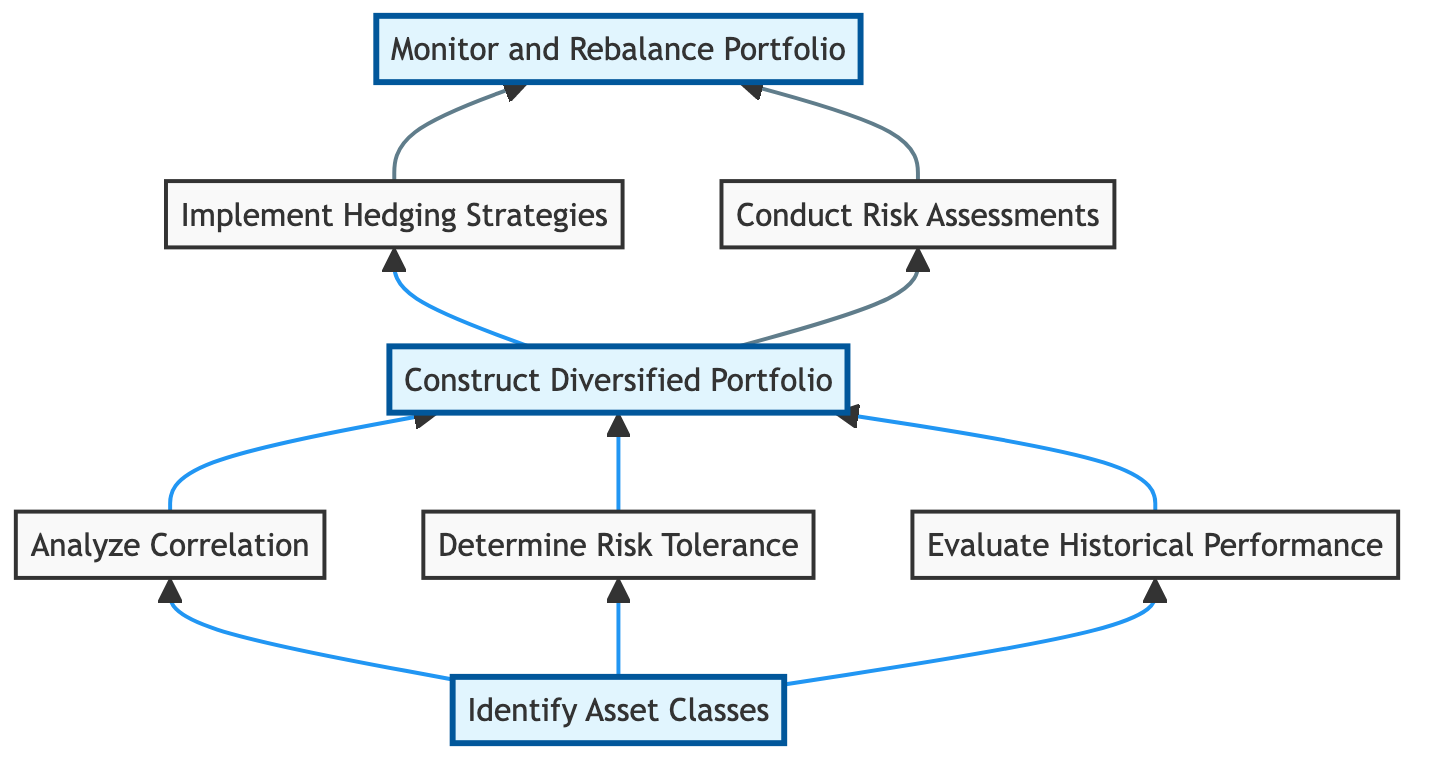What is the first step in the flow chart? The first step is to "Identify Asset Classes" as it is the first element in the diagram that signifies the starting point of the flow.
Answer: Identify Asset Classes How many elements are in the diagram? There are a total of eight elements shown in the diagram, identified by the nodes representing different actions in the portfolio diversification analysis.
Answer: Eight What steps occur before "Construct Diversified Portfolio"? The steps that occur before "Construct Diversified Portfolio" are "Analyze Correlation", "Determine Risk Tolerance", and "Evaluate Historical Performance", as illustrated by the arrows leading into the construction step.
Answer: Analyze Correlation, Determine Risk Tolerance, Evaluate Historical Performance Which element is connected to "Monitor and Rebalance Portfolio"? "Monitor and Rebalance Portfolio" is connected to both "Implement Hedging Strategies" and "Conduct Risk Assessments", as indicated by the directional arrows leading into this node.
Answer: Implement Hedging Strategies, Conduct Risk Assessments What is the relationship between "Evaluate Historical Performance" and "Construct Diversified Portfolio"? "Evaluate Historical Performance" directly feeds into "Construct Diversified Portfolio", indicating that the outcomes of evaluating historical performance influence the construction of the portfolio.
Answer: Direct influence What happens after "Conduct Risk Assessments"? After "Conduct Risk Assessments", the next action is "Monitor and Rebalance Portfolio", meaning that ongoing monitoring and adjustments follow the risk assessments conducted for the portfolio.
Answer: Monitor and Rebalance Portfolio Which step has no outgoing connections? The step "Identify Asset Classes" has no outgoing connections, indicating it is the starting point of the flow without a prerequisite step leading into it.
Answer: Identify Asset Classes How many slots are highlighted in the diagram? There are four highlighted slots in the diagram, representing key focus areas within the portfolio diversification analysis process.
Answer: Four What is the final step in the flow chart? The final step in the flow chart is "Monitor and Rebalance Portfolio", which comes after all prior assessment and construction steps are completed.
Answer: Monitor and Rebalance Portfolio 